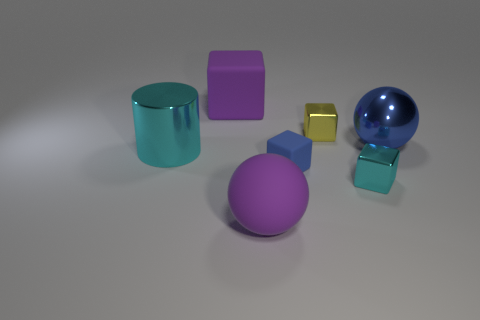There is a metallic block that is the same color as the big cylinder; what is its size?
Make the answer very short. Small. Are there any purple rubber spheres that have the same size as the yellow object?
Your response must be concise. No. Is the material of the large blue thing the same as the cyan object that is in front of the blue rubber block?
Offer a very short reply. Yes. Is the number of spheres greater than the number of purple metallic things?
Your answer should be very brief. Yes. How many cubes are cyan shiny objects or blue matte things?
Your answer should be very brief. 2. What is the color of the large metallic cylinder?
Ensure brevity in your answer.  Cyan. There is a matte cube behind the yellow metal cube; is its size the same as the purple object that is in front of the cyan metallic cylinder?
Your answer should be compact. Yes. Are there fewer yellow objects than small brown balls?
Make the answer very short. No. What number of metallic cylinders are in front of the small cyan shiny object?
Make the answer very short. 0. What is the blue ball made of?
Provide a short and direct response. Metal. 